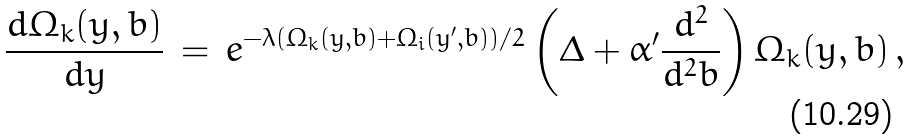Convert formula to latex. <formula><loc_0><loc_0><loc_500><loc_500>\frac { d \Omega _ { k } ( y , b ) } { d y } \, = \, e ^ { - \lambda ( \Omega _ { k } ( y , b ) + \Omega _ { i } ( y ^ { \prime } , b ) ) / 2 } \left ( \Delta + \alpha ^ { \prime } \frac { d ^ { 2 } } { d ^ { 2 } b } \right ) \Omega _ { k } ( y , b ) \, ,</formula> 